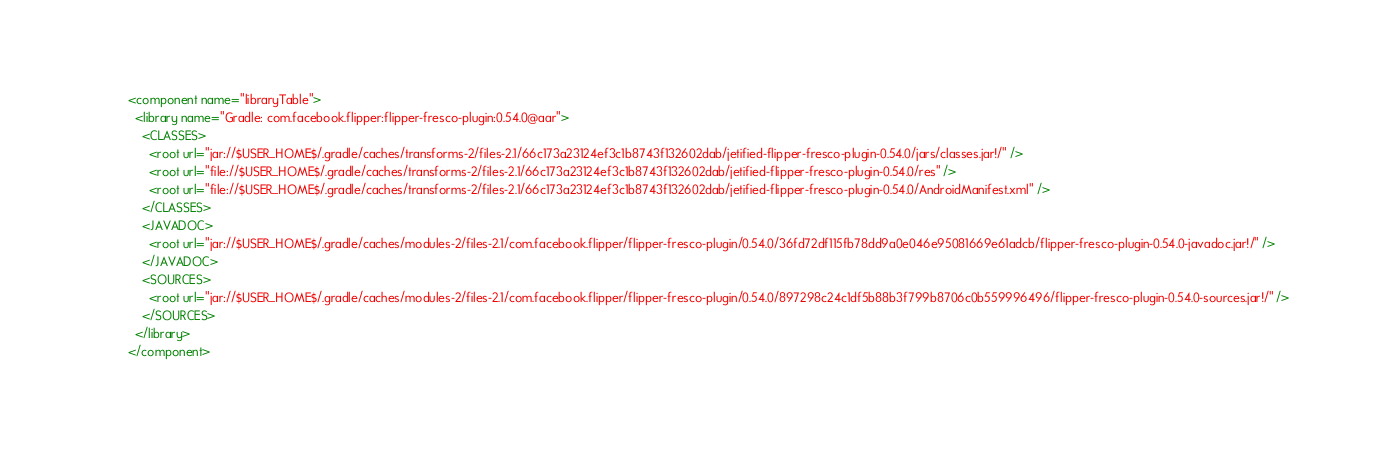<code> <loc_0><loc_0><loc_500><loc_500><_XML_><component name="libraryTable">
  <library name="Gradle: com.facebook.flipper:flipper-fresco-plugin:0.54.0@aar">
    <CLASSES>
      <root url="jar://$USER_HOME$/.gradle/caches/transforms-2/files-2.1/66c173a23124ef3c1b8743f132602dab/jetified-flipper-fresco-plugin-0.54.0/jars/classes.jar!/" />
      <root url="file://$USER_HOME$/.gradle/caches/transforms-2/files-2.1/66c173a23124ef3c1b8743f132602dab/jetified-flipper-fresco-plugin-0.54.0/res" />
      <root url="file://$USER_HOME$/.gradle/caches/transforms-2/files-2.1/66c173a23124ef3c1b8743f132602dab/jetified-flipper-fresco-plugin-0.54.0/AndroidManifest.xml" />
    </CLASSES>
    <JAVADOC>
      <root url="jar://$USER_HOME$/.gradle/caches/modules-2/files-2.1/com.facebook.flipper/flipper-fresco-plugin/0.54.0/36fd72df115fb78dd9a0e046e95081669e61adcb/flipper-fresco-plugin-0.54.0-javadoc.jar!/" />
    </JAVADOC>
    <SOURCES>
      <root url="jar://$USER_HOME$/.gradle/caches/modules-2/files-2.1/com.facebook.flipper/flipper-fresco-plugin/0.54.0/897298c24c1df5b88b3f799b8706c0b559996496/flipper-fresco-plugin-0.54.0-sources.jar!/" />
    </SOURCES>
  </library>
</component></code> 